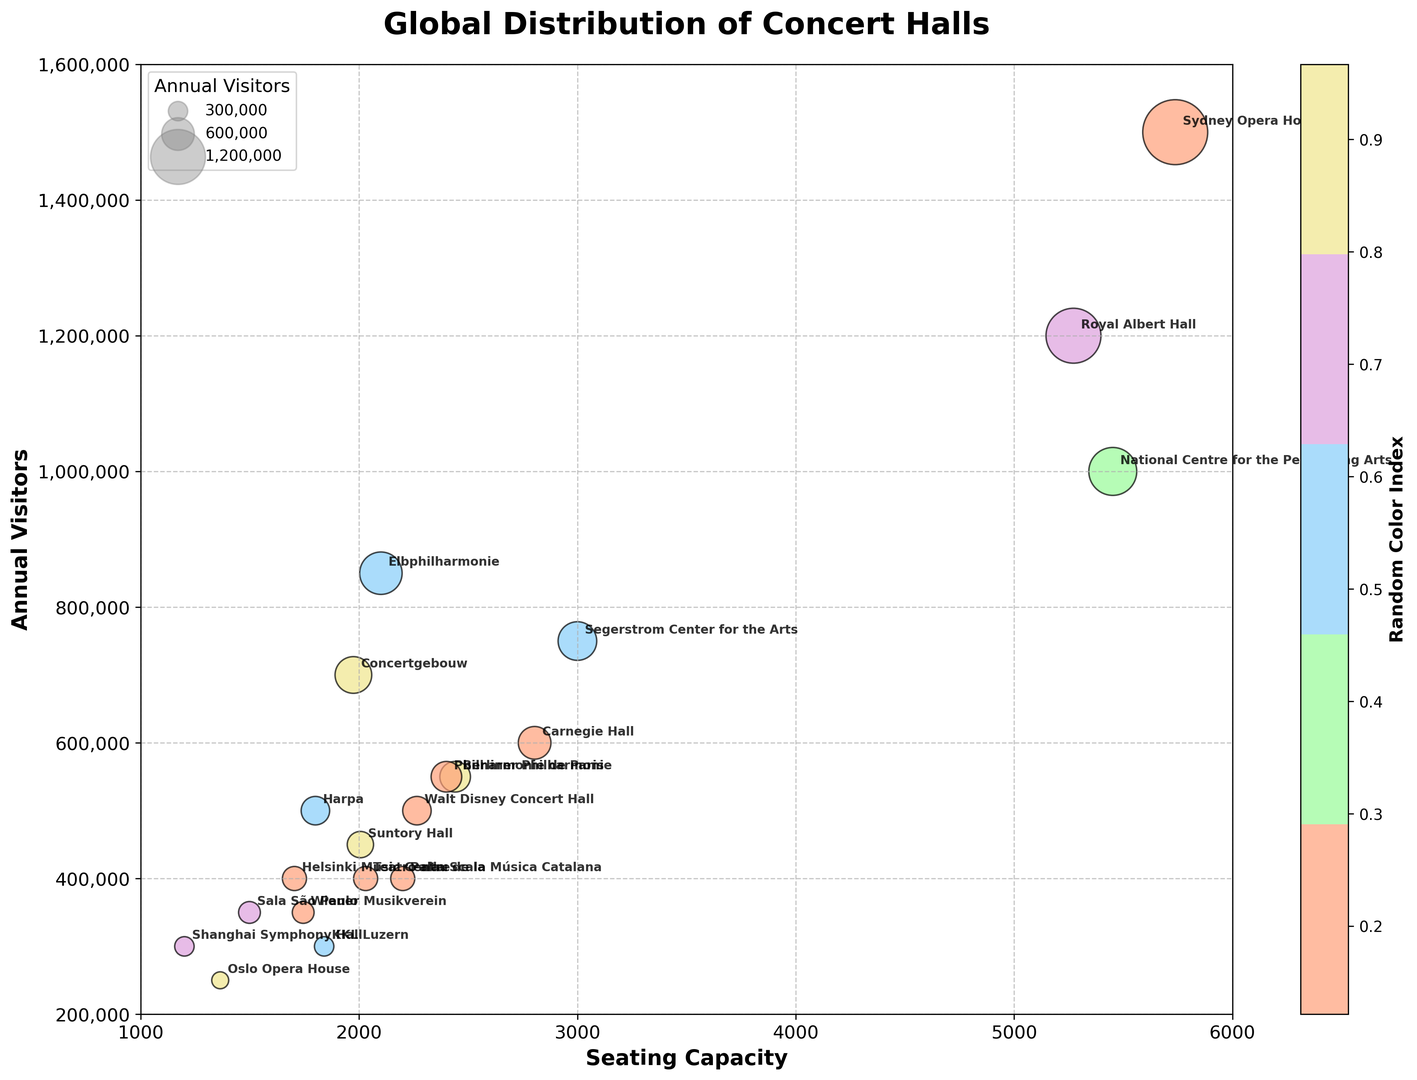Which concert hall has the highest number of annual visitors? The plot shows bubbles sized proportionally to their annual visitors. The largest bubble corresponds to the Sydney Opera House, indicating it has the highest number of annual visitors.
Answer: Sydney Opera House How many concert halls have seating capacities greater than 3000? By examining the x-axis for seating capacities and identifying the bubbles to the right of the 3000 mark, we see that there are five concert halls meeting this criterion.
Answer: 5 Which city has more annual visitors, New York or Costa Mesa? The plot shows Carnegie Hall (New York) and Segerstrom Center for the Arts (Costa Mesa). By comparing the y-positions (annual visitors), it’s clear that Costa Mesa's Segerstrom Center's bubble is higher.
Answer: Costa Mesa How does the seating capacity of the Walt Disney Concert Hall compare to that of the Teatro alla Scala? Both concert halls appear this way: Walt Disney Concert Hall has a seating capacity of 2265, while Teatro alla Scala has a capacity of 2030. Since 2265 is greater than 2030, Walt Disney Concert Hall has a larger seating capacity.
Answer: Walt Disney Concert Hall Which country has the most concert halls represented in this plot? By counting the number of occurrences for each country label next to the bubbles, the USA appears the most with Carnegie Hall, Walt Disney Concert Hall, and Segerstrom Center for the Arts.
Answer: USA If you sum the seating capacities of the Royal Albert Hall and the Sydney Opera House, what do you get? The seating capacities of Royal Albert Hall and Sydney Opera House are 5272 and 5738 respectively. Adding them gives 5272 + 5738 = 11010.
Answer: 11010 Which concert hall has the smallest bubble in terms of annual visitors? The plot shows the Shanghai Symphony Hall in China has the smallest bubble, indicating the smallest number of annual visitors.
Answer: Shanghai Symphony Hall Compare the annual visitors of Elbphilharmonie in Hamburg and Berliner Philharmonie in Berlin. Which has more? Elbphilharmonie and Berliner Philharmonie are compared by their y-axis values, showing Elbphilharmonie's bubble higher, denoting more visitors.
Answer: Elbphilharmonie What is the combined average of annual visitors for Teatro alla Scala and Suntory Hall? Teatro alla Scala and Suntory Hall have annual visitors of 400,000 and 450,000 respectively. The average is calculated as (400,000 + 450,000) / 2 = 425,000.
Answer: 425,000 Which concert hall’s bubble appears in the color closest to red among all others? By examining the visual attributes, the Royal Albert Hall's bubble visually stands out with a color closest to red in the plot.
Answer: Royal Albert Hall 